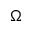<formula> <loc_0><loc_0><loc_500><loc_500>\Omega</formula> 